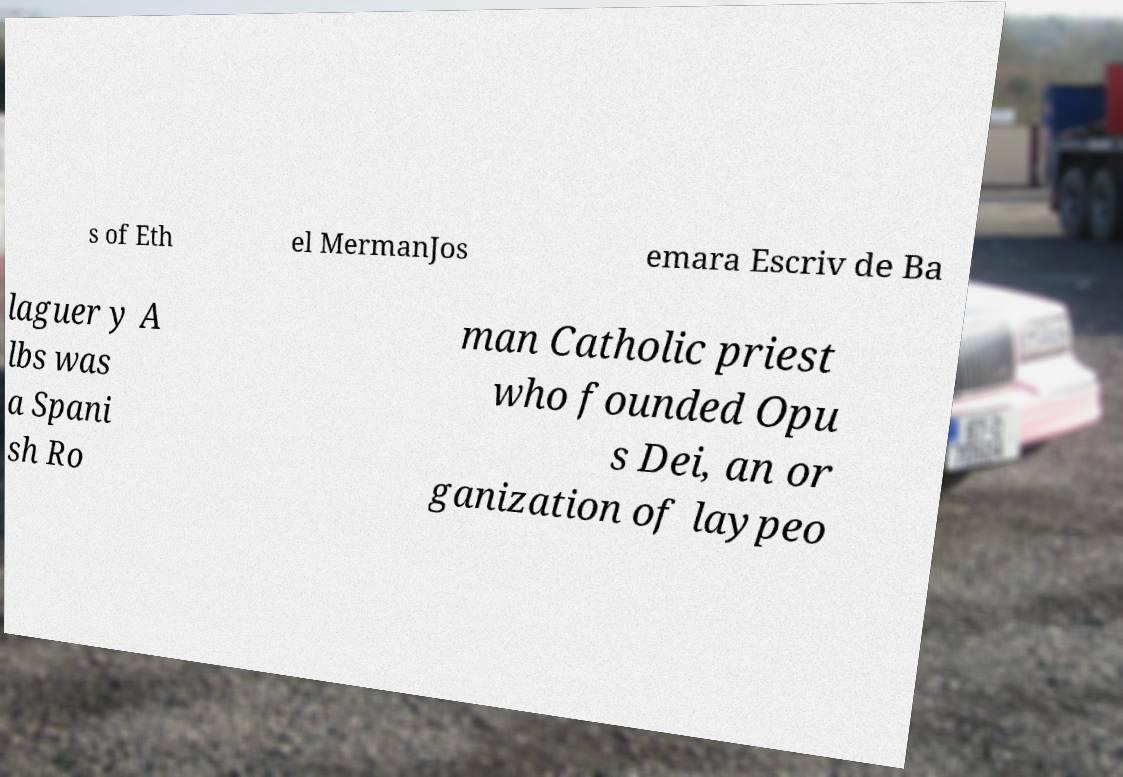Could you assist in decoding the text presented in this image and type it out clearly? s of Eth el MermanJos emara Escriv de Ba laguer y A lbs was a Spani sh Ro man Catholic priest who founded Opu s Dei, an or ganization of laypeo 